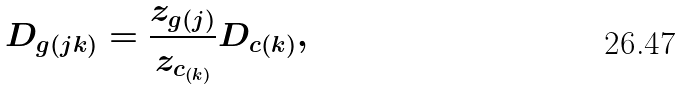<formula> <loc_0><loc_0><loc_500><loc_500>D _ { g ( j k ) } = \frac { z _ { g ( j ) } } { z _ { c _ { ( k ) } } } D _ { c ( k ) } ,</formula> 